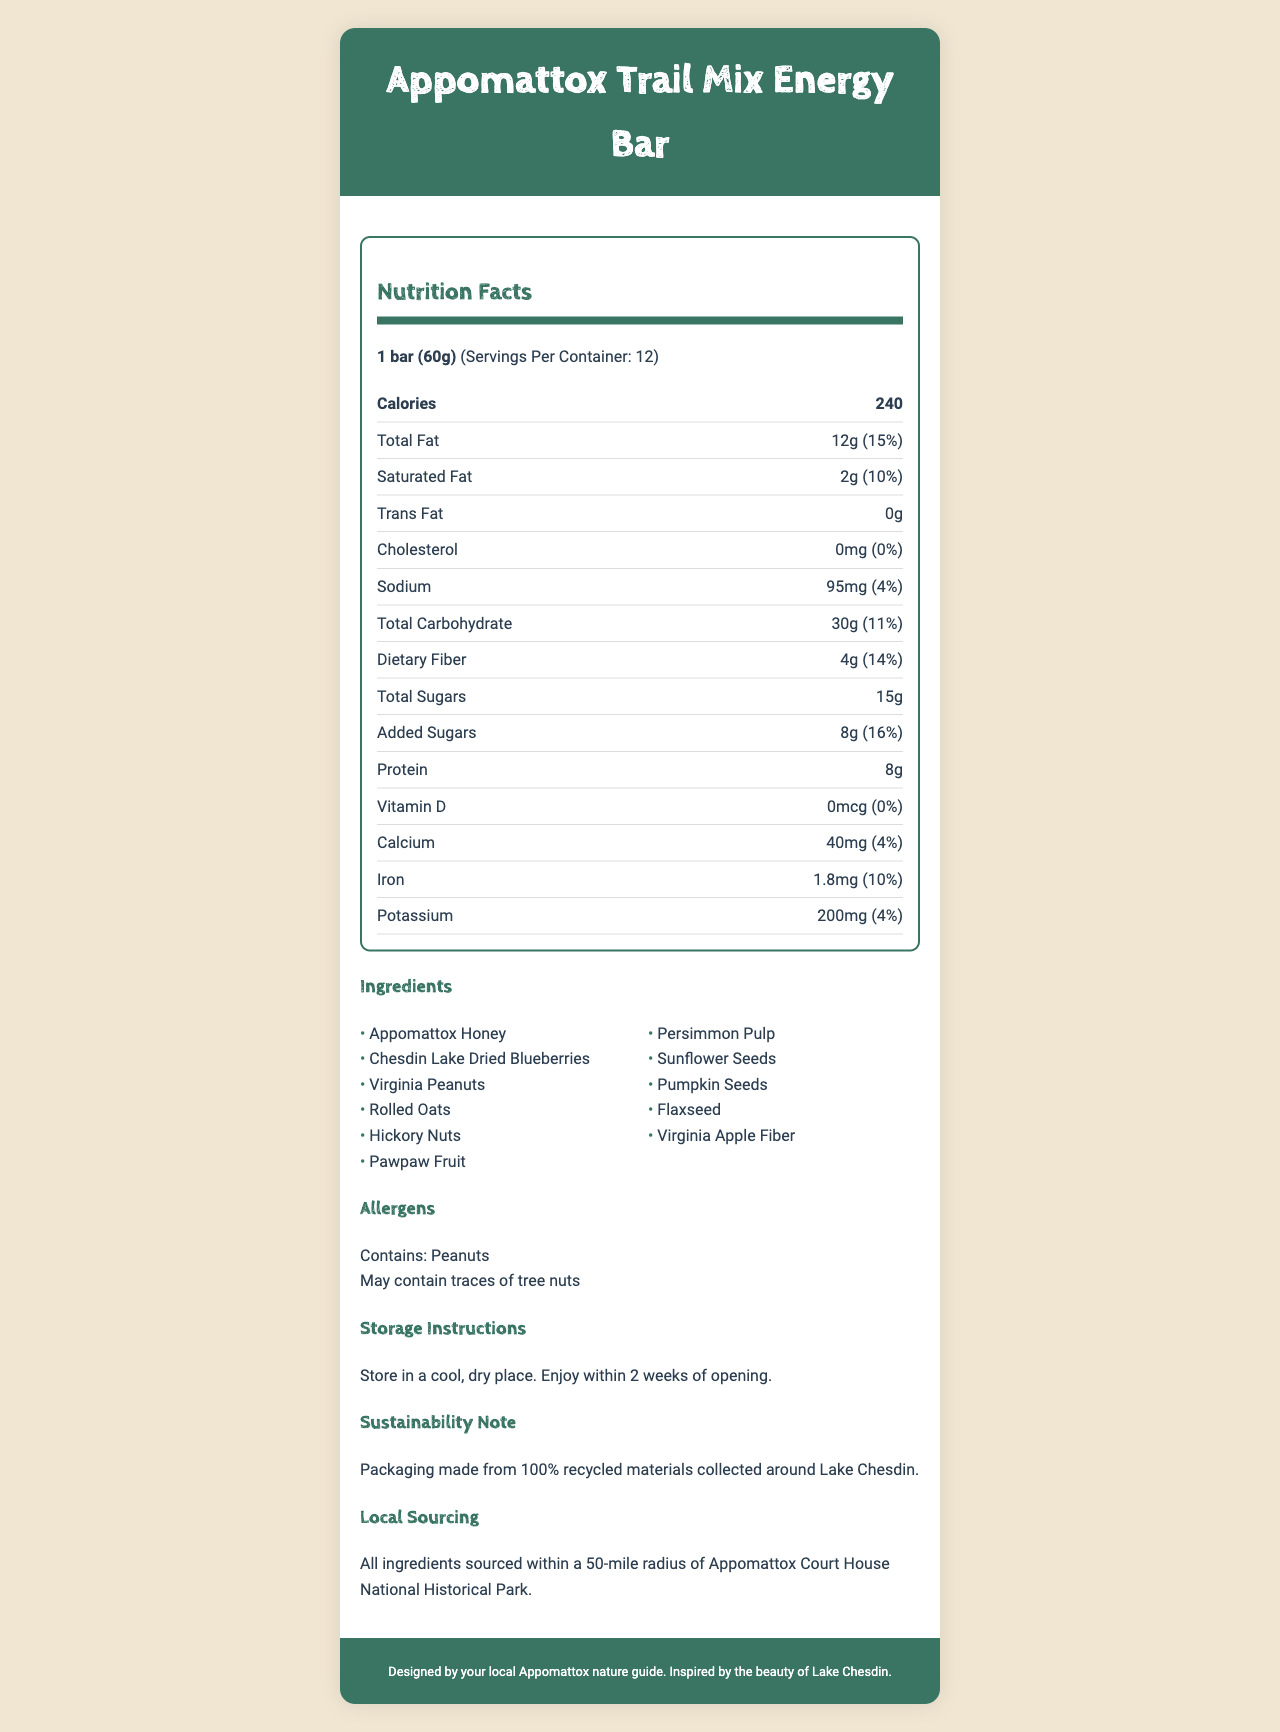What is the serving size for the Appomattox Trail Mix Energy Bar? The serving size is listed at the top of the Nutrition Facts section as "1 bar (60g)".
Answer: 1 bar (60g) How many calories are in one serving of the energy bar? The number of calories per serving is clearly indicated in the bolded "Calories" line.
Answer: 240 How much total fat is in each serving, and what is its daily value percentage? The total fat content is noted as 12g, with a daily value percentage of 15%.
Answer: 12g, 15% Which three ingredients are native to the Appomattox region? These ingredients are commonly associated with the Appomattox region and are listed among the ingredients.
Answer: Appomattox Honey, Chesdin Lake Dried Blueberries, Virginia Peanuts How much dietary fiber does the energy bar contain? The dietary fiber content is explicitly stated as 4g, with a daily value of 14%.
Answer: 4g What is the amount of sodium in the energy bar? The amount of sodium is listed as 95mg with a 4% daily value.
Answer: 95mg How many grams of added sugars are there per serving? The document lists added sugars as 8g per serving, representing 16% of the daily value.
Answer: 8g Identify the vitamins and minerals included in the label along with their respective daily values. The specific vitamins and minerals along with their daily values are listed separately toward the bottom of the nutrition label.
Answer: Vitamin D (0% Daily Value), Calcium (4% Daily Value), Iron (10% Daily Value), Potassium (4% Daily Value) Which of these ingredients is NOT listed in the energy bar? A. Flaxseed B. Sunflower Seeds C. Chia Seeds The ingredients list includes Flaxseed and Sunflower Seeds, but not Chia Seeds.
Answer: C. Chia Seeds Is there any cholesterol in the Appomattox Trail Mix Energy Bar? The document clearly states that the cholesterol amount is 0mg, which means there is no cholesterol.
Answer: No Does the energy bar contain any trans fat? The nutrition label explicitly mentions that the trans fat content is 0g, indicating the absence of trans fat.
Answer: No What are the steps for storing the energy bar? A. Store in a cool, dry place B. Keep refrigerated at all times C. Store at room temperature The storage instructions state that the bar should be stored in a cool, dry place and enjoyed within 2 weeks of opening.
Answer: A. Store in a cool, dry place Summarize the overall nutrition and packaging information for the Appomattox Trail Mix Energy Bar. The summary highlights the main components of the nutrition facts, ingredient sourcing, and the sustainability note, encapsulating the essential information provided in the document.
Answer: The Appomattox Trail Mix Energy Bar contains 240 calories per serving, with various nutrients like 12g of total fat, 30g of carbohydrates, 4g of dietary fiber, and 8g of protein. It has no cholesterol or trans fat and contains ingredients sourced locally. The packaging is sustainable, made from 100% recycled materials from around Lake Chesdin. What is the environmental note mentioned in the document related to packaging? The document includes a sustainability note stating that the packaging is made from 100% recycled materials collected around Lake Chesdin.
Answer: Packaging made from 100% recycled materials collected around Lake Chesdin Are the ingredients sourced locally? The document specifies that all ingredients are sourced within a 50-mile radius of Appomattox Court House National Historical Park.
Answer: Yes What is the main energy source for this energy bar? The document provides detailed nutrition information but does not specify which ingredient is the primary energy source.
Answer: Cannot be determined 